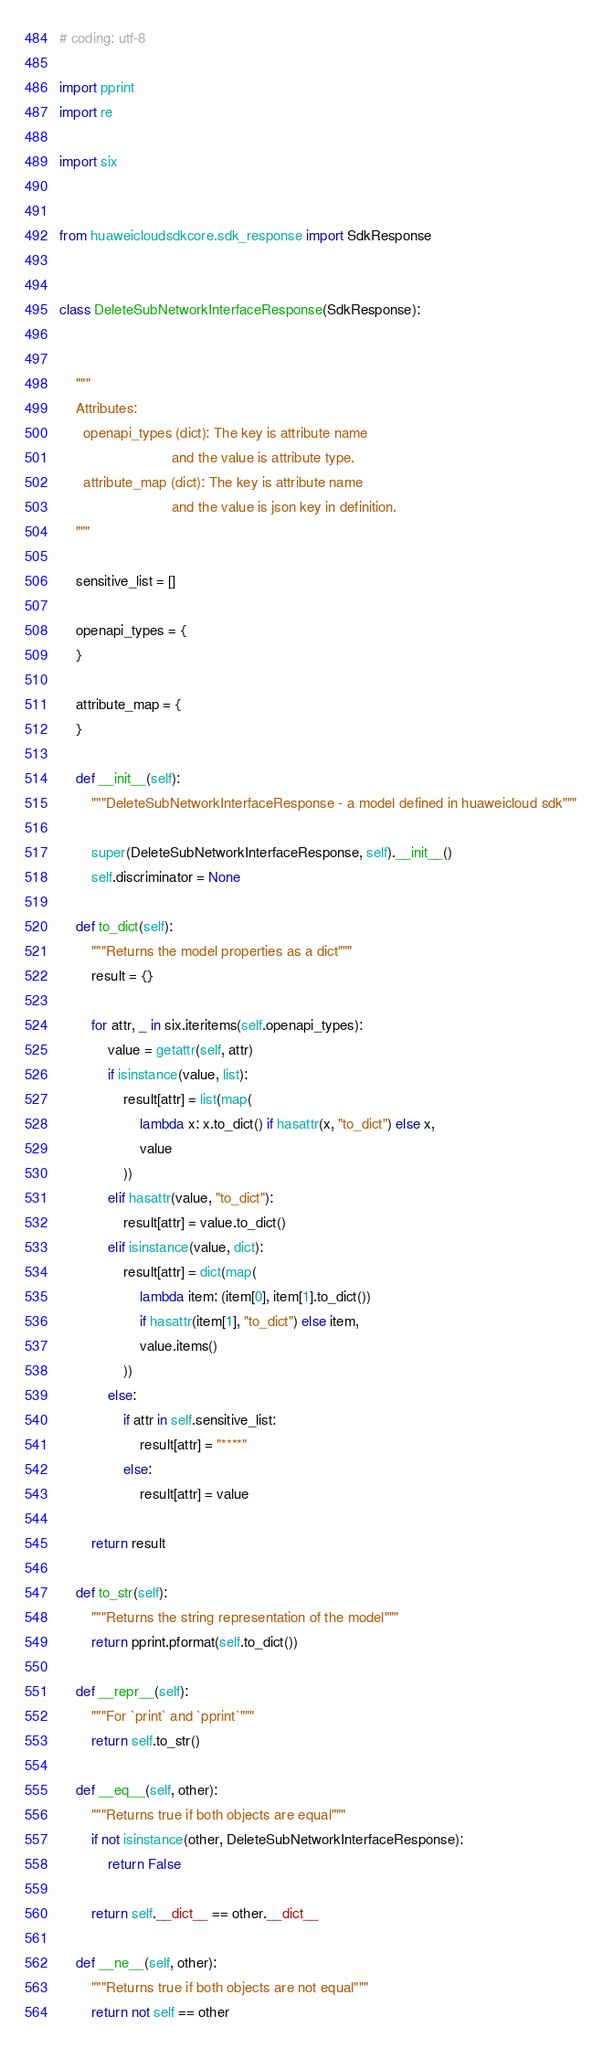Convert code to text. <code><loc_0><loc_0><loc_500><loc_500><_Python_># coding: utf-8

import pprint
import re

import six


from huaweicloudsdkcore.sdk_response import SdkResponse


class DeleteSubNetworkInterfaceResponse(SdkResponse):


    """
    Attributes:
      openapi_types (dict): The key is attribute name
                            and the value is attribute type.
      attribute_map (dict): The key is attribute name
                            and the value is json key in definition.
    """

    sensitive_list = []

    openapi_types = {
    }

    attribute_map = {
    }

    def __init__(self):
        """DeleteSubNetworkInterfaceResponse - a model defined in huaweicloud sdk"""
        
        super(DeleteSubNetworkInterfaceResponse, self).__init__()
        self.discriminator = None

    def to_dict(self):
        """Returns the model properties as a dict"""
        result = {}

        for attr, _ in six.iteritems(self.openapi_types):
            value = getattr(self, attr)
            if isinstance(value, list):
                result[attr] = list(map(
                    lambda x: x.to_dict() if hasattr(x, "to_dict") else x,
                    value
                ))
            elif hasattr(value, "to_dict"):
                result[attr] = value.to_dict()
            elif isinstance(value, dict):
                result[attr] = dict(map(
                    lambda item: (item[0], item[1].to_dict())
                    if hasattr(item[1], "to_dict") else item,
                    value.items()
                ))
            else:
                if attr in self.sensitive_list:
                    result[attr] = "****"
                else:
                    result[attr] = value

        return result

    def to_str(self):
        """Returns the string representation of the model"""
        return pprint.pformat(self.to_dict())

    def __repr__(self):
        """For `print` and `pprint`"""
        return self.to_str()

    def __eq__(self, other):
        """Returns true if both objects are equal"""
        if not isinstance(other, DeleteSubNetworkInterfaceResponse):
            return False

        return self.__dict__ == other.__dict__

    def __ne__(self, other):
        """Returns true if both objects are not equal"""
        return not self == other
</code> 